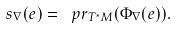Convert formula to latex. <formula><loc_0><loc_0><loc_500><loc_500>s _ { \nabla } ( e ) = \ p r _ { T ^ { * } M } ( \Phi _ { \nabla } ( e ) ) .</formula> 